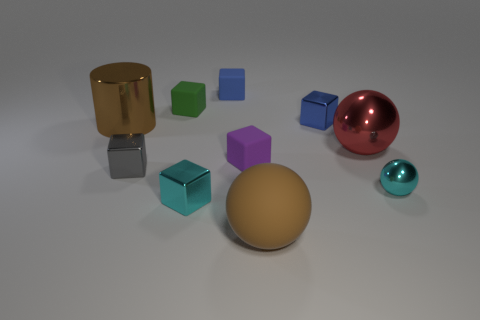Subtract 2 cubes. How many cubes are left? 4 Subtract all tiny cyan blocks. How many blocks are left? 5 Subtract all gray cubes. How many cubes are left? 5 Subtract all purple cubes. Subtract all blue cylinders. How many cubes are left? 5 Subtract all spheres. How many objects are left? 7 Subtract all brown cubes. Subtract all blue metallic cubes. How many objects are left? 9 Add 1 tiny purple rubber blocks. How many tiny purple rubber blocks are left? 2 Add 6 brown rubber things. How many brown rubber things exist? 7 Subtract 1 brown spheres. How many objects are left? 9 